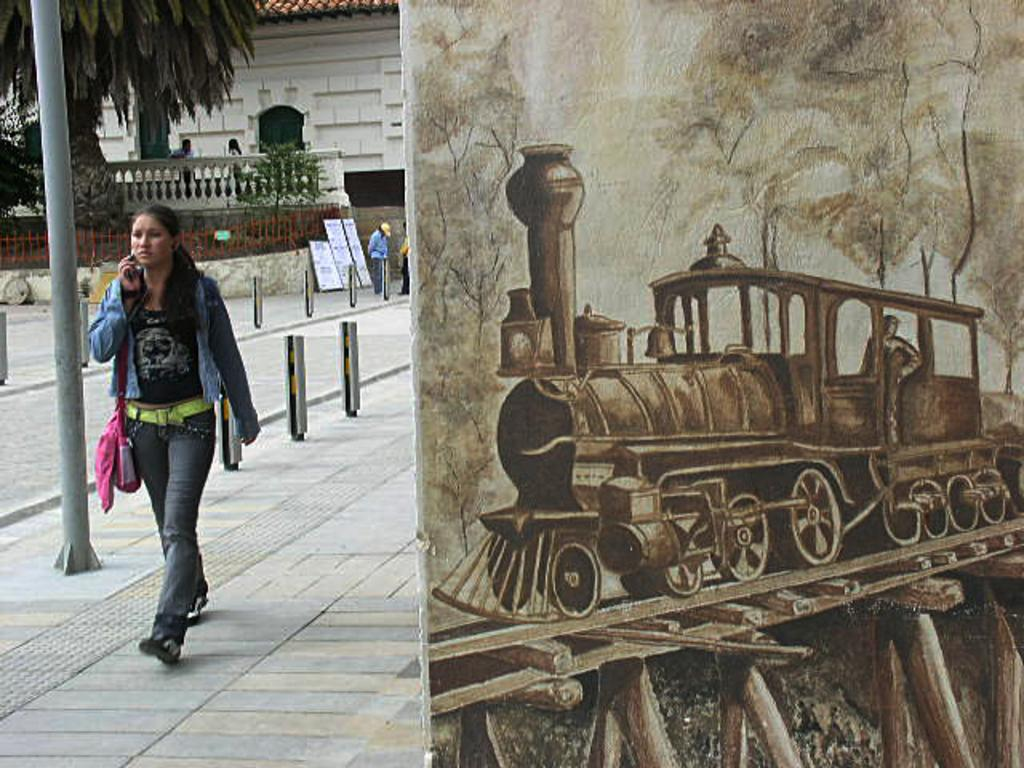How many people are in the group visible in the image? There is a group of people standing in the image, but the exact number cannot be determined from the provided facts. What type of objects can be seen in the image besides the people? There are boards, iron grilles, trees, and a painting on a wall visible in the image. What type of structure might the image depict? The image appears to depict a house. How many pears are on the ground in the image? There is no mention of pears in the provided facts, so we cannot determine if any are present in the image. 